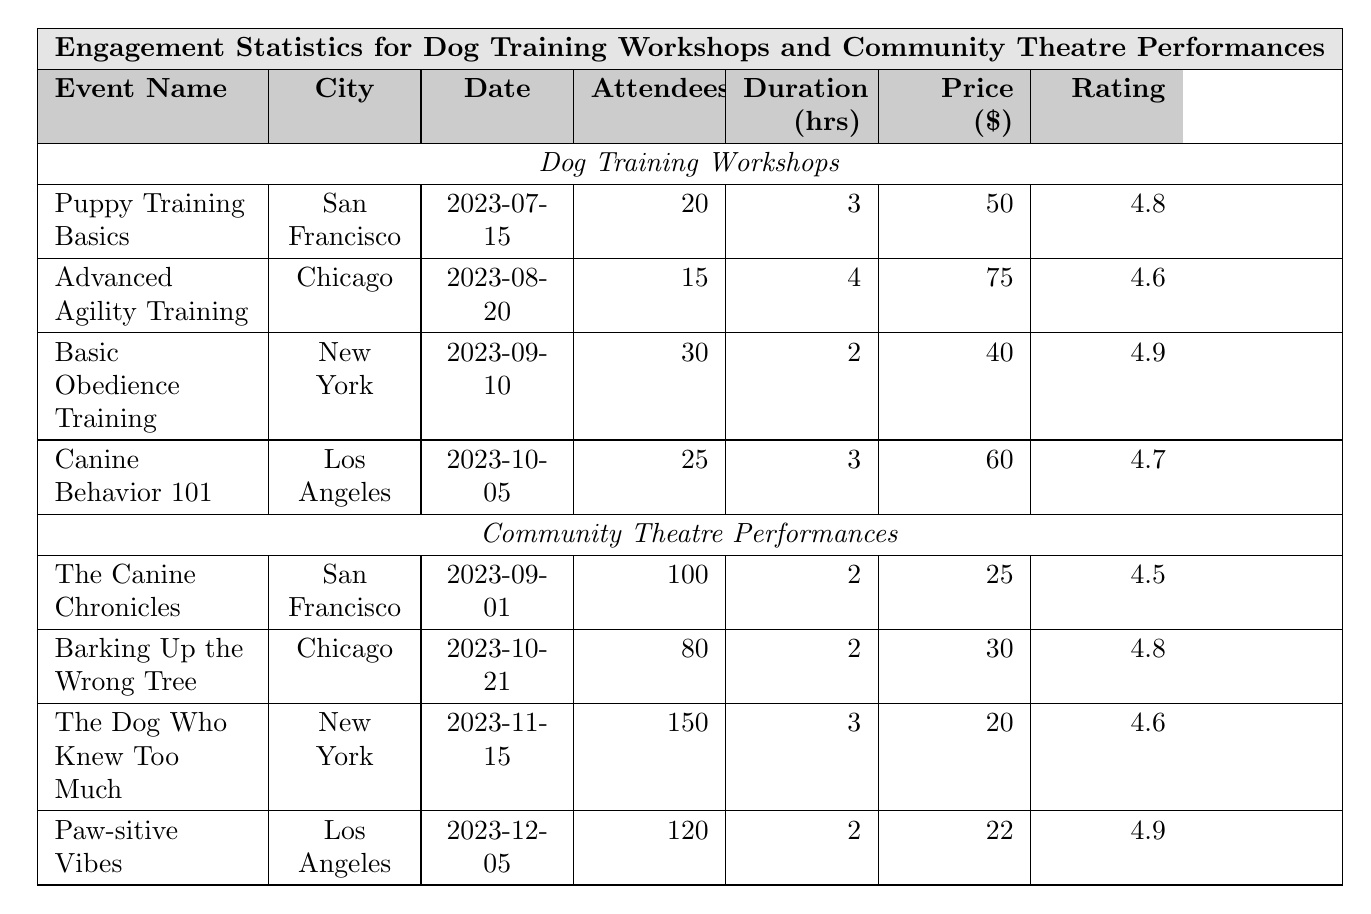What is the highest feedback score for a dog training workshop? The highest feedback score is found by comparing the scores for each workshop: 4.8, 4.6, 4.9, and 4.7. The highest of these is 4.9 for the Basic Obedience Training workshop.
Answer: 4.9 Which city had the most attendees for a community theatre performance? The attendees for each theatre performance are as follows: The Canine Chronicles (100), Barking Up the Wrong Tree (80), The Dog Who Knew Too Much (150), and Paw-sitive Vibes (120). The highest is 150 for The Dog Who Knew Too Much in New York.
Answer: New York What is the total fee collected from participants in the Advanced Agility Training workshop? The fee per participant is $75, and there were 15 participants. Therefore, total fee = 15 * 75 = 1125.
Answer: 1125 How many workshops had more than 20 participants? The participants for the workshops are: 20 (Puppy Training Basics), 15 (Advanced Agility Training), 30 (Basic Obedience Training), and 25 (Canine Behavior 101). Only Basic Obedience Training and Canine Behavior 101 had more than 20 participants, totaling to 2 workshops.
Answer: 2 What is the average duration of the dog training workshops? The durations are 3, 4, 2, and 3 hours. The average duration is calculated as (3 + 4 + 2 + 3) / 4 = 12 / 4 = 3 hours.
Answer: 3 hours Did any community theatre performance have a ticket price lower than $25? The ticket prices for each performance are: $25 (The Canine Chronicles), $30 (Barking Up the Wrong Tree), $20 (The Dog Who Knew Too Much), and $22 (Paw-sitive Vibes). The Dog Who Knew Too Much has a ticket price of $20, which is lower than $25.
Answer: Yes What is the difference in feedback score between the highest and lowest scoring dog training workshops? The highest feedback score is 4.9 and the lowest is 4.6. The difference is calculated as 4.9 - 4.6 = 0.3.
Answer: 0.3 Which workshop had the longest duration and what was that duration? The durations of the workshops are as follows: 3 hours (Puppy Training Basics), 4 hours (Advanced Agility Training), 2 hours (Basic Obedience Training), and 3 hours (Canine Behavior 101). The longest duration is 4 hours for Advanced Agility Training.
Answer: 4 hours How many theatre performances took place in San Francisco? The two performances in San Francisco are The Canine Chronicles and Puppy Training Basics, making a total of 2 performances.
Answer: 2 Which dog training workshop had the least fee per participant? The fees for the workshops are $50 (Puppy Training Basics), $75 (Advanced Agility Training), $40 (Basic Obedience Training), and $60 (Canine Behavior 101). The least fee is $40 for Basic Obedience Training.
Answer: $40 